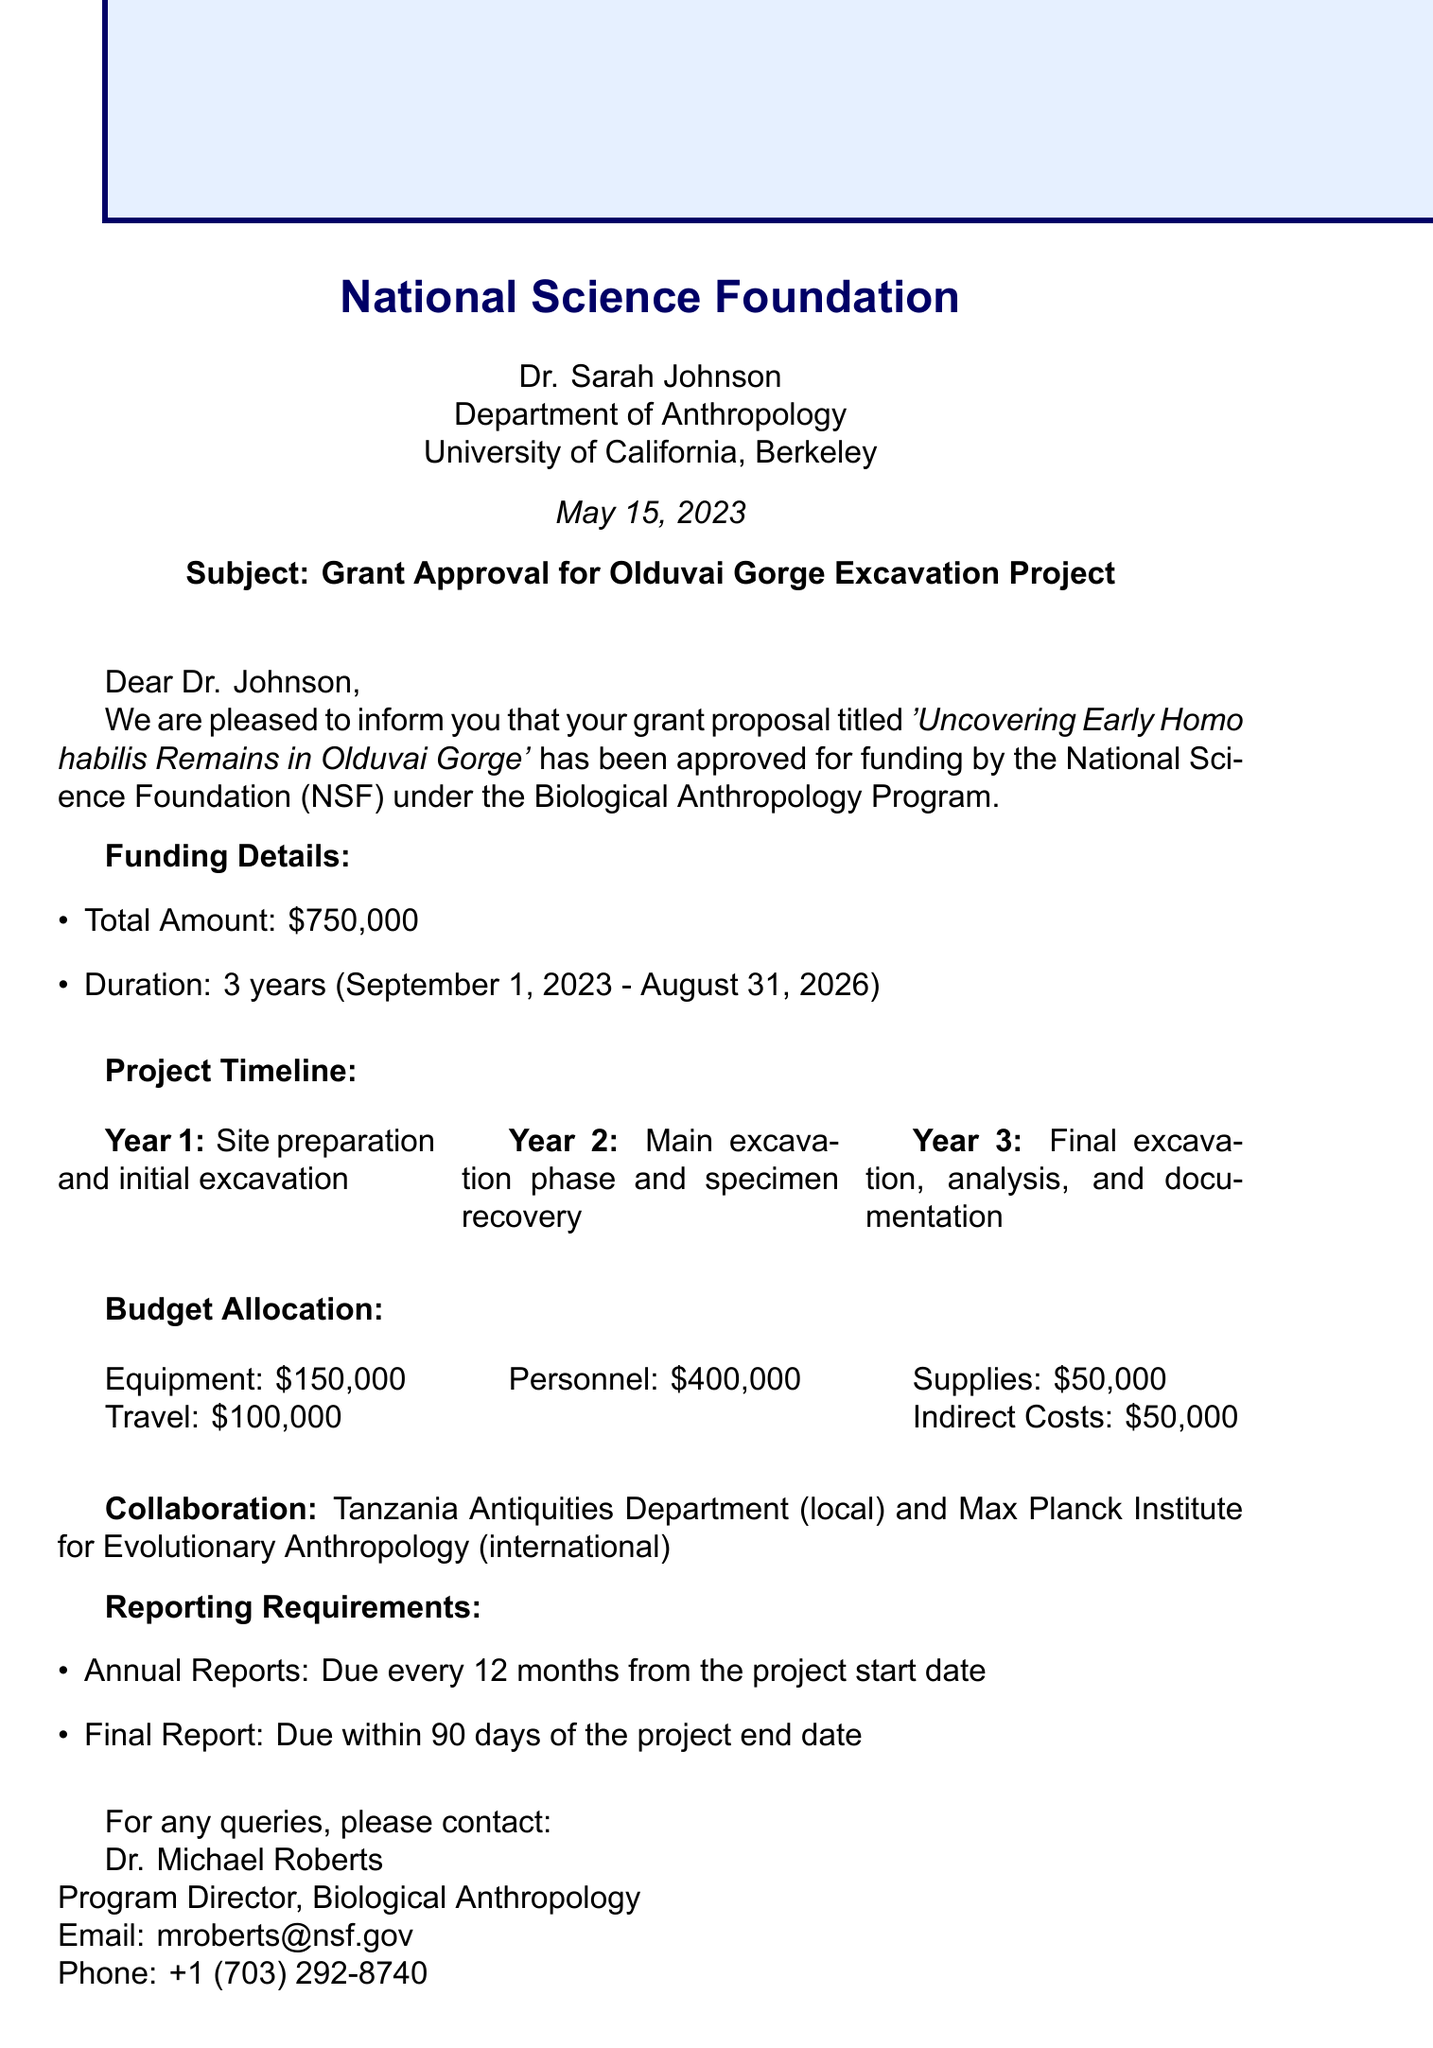What is the total funding allocated for the project? The document specifies that the total funding allocated for the project is $750,000.
Answer: $750,000 When does the project start? The starting date of the project is mentioned in the funding details section.
Answer: September 1, 2023 Who is the local partner for the excavation project? The document lists the local partner as the Tanzania Antiquities Department.
Answer: Tanzania Antiquities Department What is the duration of the grant? The letter states the duration of the grant in years.
Answer: 3 years What is the final report due date? The report section outlines the timeline for the final report, stating it is due within a specific time frame after the project ends.
Answer: Within 90 days of the project end date What are the primary activities in the first year? The project timeline details activities for each year; the first year focuses on specific tasks.
Answer: Site preparation and initial excavation Who is the contact person for this grant? The contact person's information is provided in the document, including their position and email.
Answer: Dr. Michael Roberts How much is allocated for equipment expenses? The budget allocation section provides the figure for equipment costs specifically.
Answer: $150,000 What is the last date of the project? The end date of the project is mentioned in the funding details.
Answer: August 31, 2026 